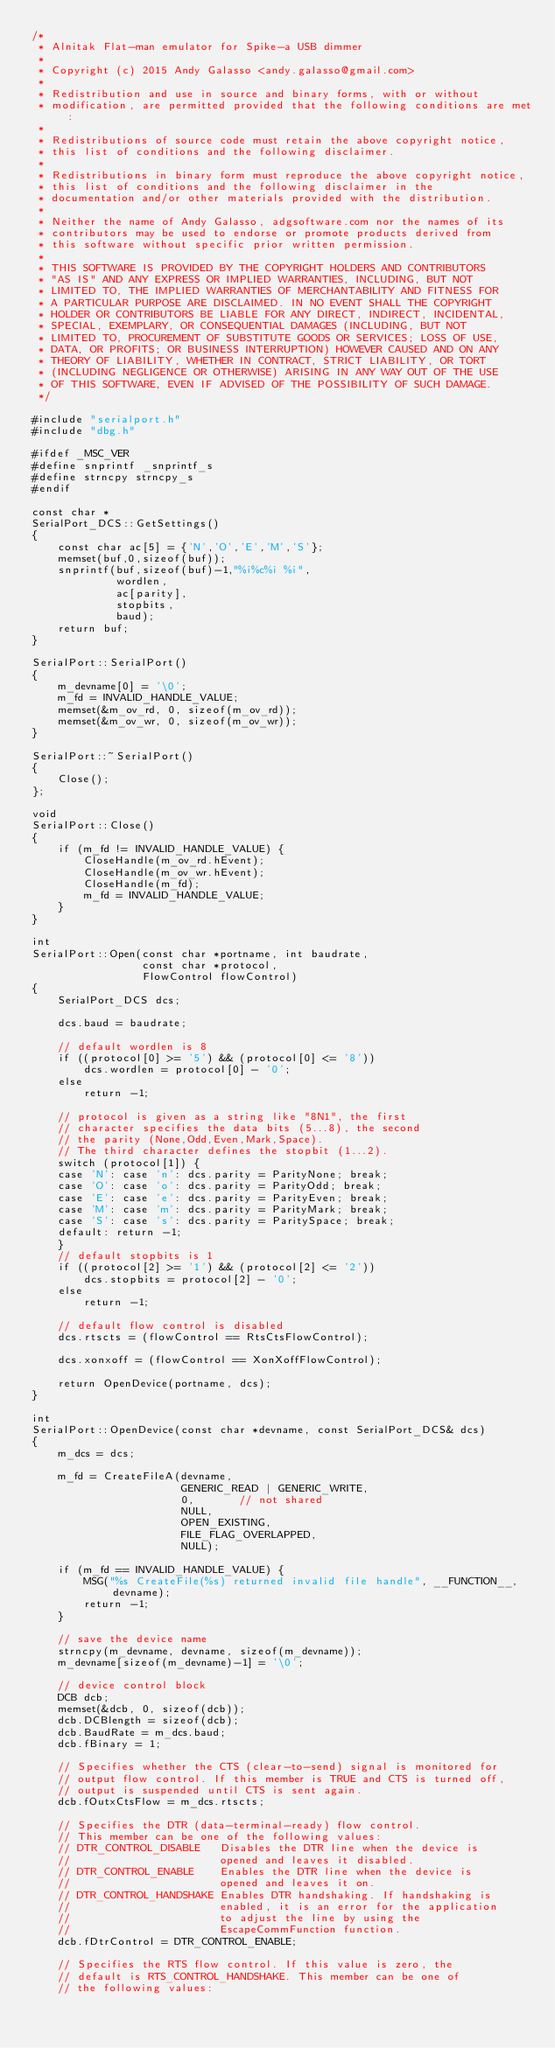<code> <loc_0><loc_0><loc_500><loc_500><_C++_>/*
 * Alnitak Flat-man emulator for Spike-a USB dimmer
 *
 * Copyright (c) 2015 Andy Galasso <andy.galasso@gmail.com>
 *
 * Redistribution and use in source and binary forms, with or without
 * modification, are permitted provided that the following conditions are met:
 *
 * Redistributions of source code must retain the above copyright notice,
 * this list of conditions and the following disclaimer.
 *
 * Redistributions in binary form must reproduce the above copyright notice,
 * this list of conditions and the following disclaimer in the
 * documentation and/or other materials provided with the distribution.
 *
 * Neither the name of Andy Galasso, adgsoftware.com nor the names of its
 * contributors may be used to endorse or promote products derived from
 * this software without specific prior written permission.
 *
 * THIS SOFTWARE IS PROVIDED BY THE COPYRIGHT HOLDERS AND CONTRIBUTORS
 * "AS IS" AND ANY EXPRESS OR IMPLIED WARRANTIES, INCLUDING, BUT NOT
 * LIMITED TO, THE IMPLIED WARRANTIES OF MERCHANTABILITY AND FITNESS FOR
 * A PARTICULAR PURPOSE ARE DISCLAIMED. IN NO EVENT SHALL THE COPYRIGHT
 * HOLDER OR CONTRIBUTORS BE LIABLE FOR ANY DIRECT, INDIRECT, INCIDENTAL,
 * SPECIAL, EXEMPLARY, OR CONSEQUENTIAL DAMAGES (INCLUDING, BUT NOT
 * LIMITED TO, PROCUREMENT OF SUBSTITUTE GOODS OR SERVICES; LOSS OF USE,
 * DATA, OR PROFITS; OR BUSINESS INTERRUPTION) HOWEVER CAUSED AND ON ANY
 * THEORY OF LIABILITY, WHETHER IN CONTRACT, STRICT LIABILITY, OR TORT
 * (INCLUDING NEGLIGENCE OR OTHERWISE) ARISING IN ANY WAY OUT OF THE USE
 * OF THIS SOFTWARE, EVEN IF ADVISED OF THE POSSIBILITY OF SUCH DAMAGE.
 */

#include "serialport.h"
#include "dbg.h"

#ifdef _MSC_VER
#define snprintf _snprintf_s
#define strncpy strncpy_s
#endif

const char *
SerialPort_DCS::GetSettings()
{
    const char ac[5] = {'N','O','E','M','S'};
    memset(buf,0,sizeof(buf));
    snprintf(buf,sizeof(buf)-1,"%i%c%i %i",
             wordlen,
             ac[parity],
             stopbits,
             baud);
    return buf;
}

SerialPort::SerialPort()
{
    m_devname[0] = '\0';
    m_fd = INVALID_HANDLE_VALUE;
    memset(&m_ov_rd, 0, sizeof(m_ov_rd));
    memset(&m_ov_wr, 0, sizeof(m_ov_wr));
}

SerialPort::~SerialPort()
{
    Close();
};

void
SerialPort::Close()
{
    if (m_fd != INVALID_HANDLE_VALUE) {
        CloseHandle(m_ov_rd.hEvent);
        CloseHandle(m_ov_wr.hEvent);
        CloseHandle(m_fd);
        m_fd = INVALID_HANDLE_VALUE;
    }
}

int
SerialPort::Open(const char *portname, int baudrate,
                 const char *protocol,
                 FlowControl flowControl)
{
    SerialPort_DCS dcs;

    dcs.baud = baudrate;

    // default wordlen is 8
    if ((protocol[0] >= '5') && (protocol[0] <= '8'))
        dcs.wordlen = protocol[0] - '0';
    else
        return -1;

    // protocol is given as a string like "8N1", the first
    // character specifies the data bits (5...8), the second
    // the parity (None,Odd,Even,Mark,Space).
    // The third character defines the stopbit (1...2).
    switch (protocol[1]) {
    case 'N': case 'n': dcs.parity = ParityNone; break;
    case 'O': case 'o': dcs.parity = ParityOdd; break;
    case 'E': case 'e': dcs.parity = ParityEven; break;
    case 'M': case 'm': dcs.parity = ParityMark; break;
    case 'S': case 's': dcs.parity = ParitySpace; break;
    default: return -1;
    }
    // default stopbits is 1
    if ((protocol[2] >= '1') && (protocol[2] <= '2'))
        dcs.stopbits = protocol[2] - '0';
    else
        return -1;

    // default flow control is disabled
    dcs.rtscts = (flowControl == RtsCtsFlowControl);

    dcs.xonxoff = (flowControl == XonXoffFlowControl);

    return OpenDevice(portname, dcs);
}

int
SerialPort::OpenDevice(const char *devname, const SerialPort_DCS& dcs)
{
    m_dcs = dcs;

    m_fd = CreateFileA(devname,
                       GENERIC_READ | GENERIC_WRITE,
                       0,		// not shared
                       NULL,
                       OPEN_EXISTING,
                       FILE_FLAG_OVERLAPPED,
                       NULL);

    if (m_fd == INVALID_HANDLE_VALUE) {
        MSG("%s CreateFile(%s) returned invalid file handle", __FUNCTION__, devname);
        return -1;
    }

    // save the device name
    strncpy(m_devname, devname, sizeof(m_devname));
    m_devname[sizeof(m_devname)-1] = '\0';

    // device control block
    DCB dcb;
    memset(&dcb, 0, sizeof(dcb));
    dcb.DCBlength = sizeof(dcb);
    dcb.BaudRate = m_dcs.baud;
    dcb.fBinary = 1;

    // Specifies whether the CTS (clear-to-send) signal is monitored for
    // output flow control. If this member is TRUE and CTS is turned off,
    // output is suspended until CTS is sent again.
    dcb.fOutxCtsFlow = m_dcs.rtscts;

    // Specifies the DTR (data-terminal-ready) flow control.
    // This member can be one of the following values:
    // DTR_CONTROL_DISABLE   Disables the DTR line when the device is
    //                       opened and leaves it disabled.
    // DTR_CONTROL_ENABLE    Enables the DTR line when the device is
    //                       opened and leaves it on.
    // DTR_CONTROL_HANDSHAKE Enables DTR handshaking. If handshaking is
    //                       enabled, it is an error for the application
    //                       to adjust the line by using the
    //                       EscapeCommFunction function.
    dcb.fDtrControl = DTR_CONTROL_ENABLE;

    // Specifies the RTS flow control. If this value is zero, the
    // default is RTS_CONTROL_HANDSHAKE. This member can be one of
    // the following values:</code> 